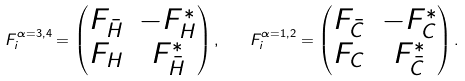<formula> <loc_0><loc_0><loc_500><loc_500>F ^ { \alpha = 3 , 4 } _ { i } = \begin{pmatrix} F _ { \bar { H } } & - F _ { H } ^ { * } \\ F _ { H } & F _ { \bar { H } } ^ { * } \end{pmatrix} , \quad F ^ { \alpha = 1 , 2 } _ { i } = \begin{pmatrix} F _ { \bar { C } } & - F _ { C } ^ { * } \\ F _ { C } & F _ { \bar { C } } ^ { * } \end{pmatrix} .</formula> 